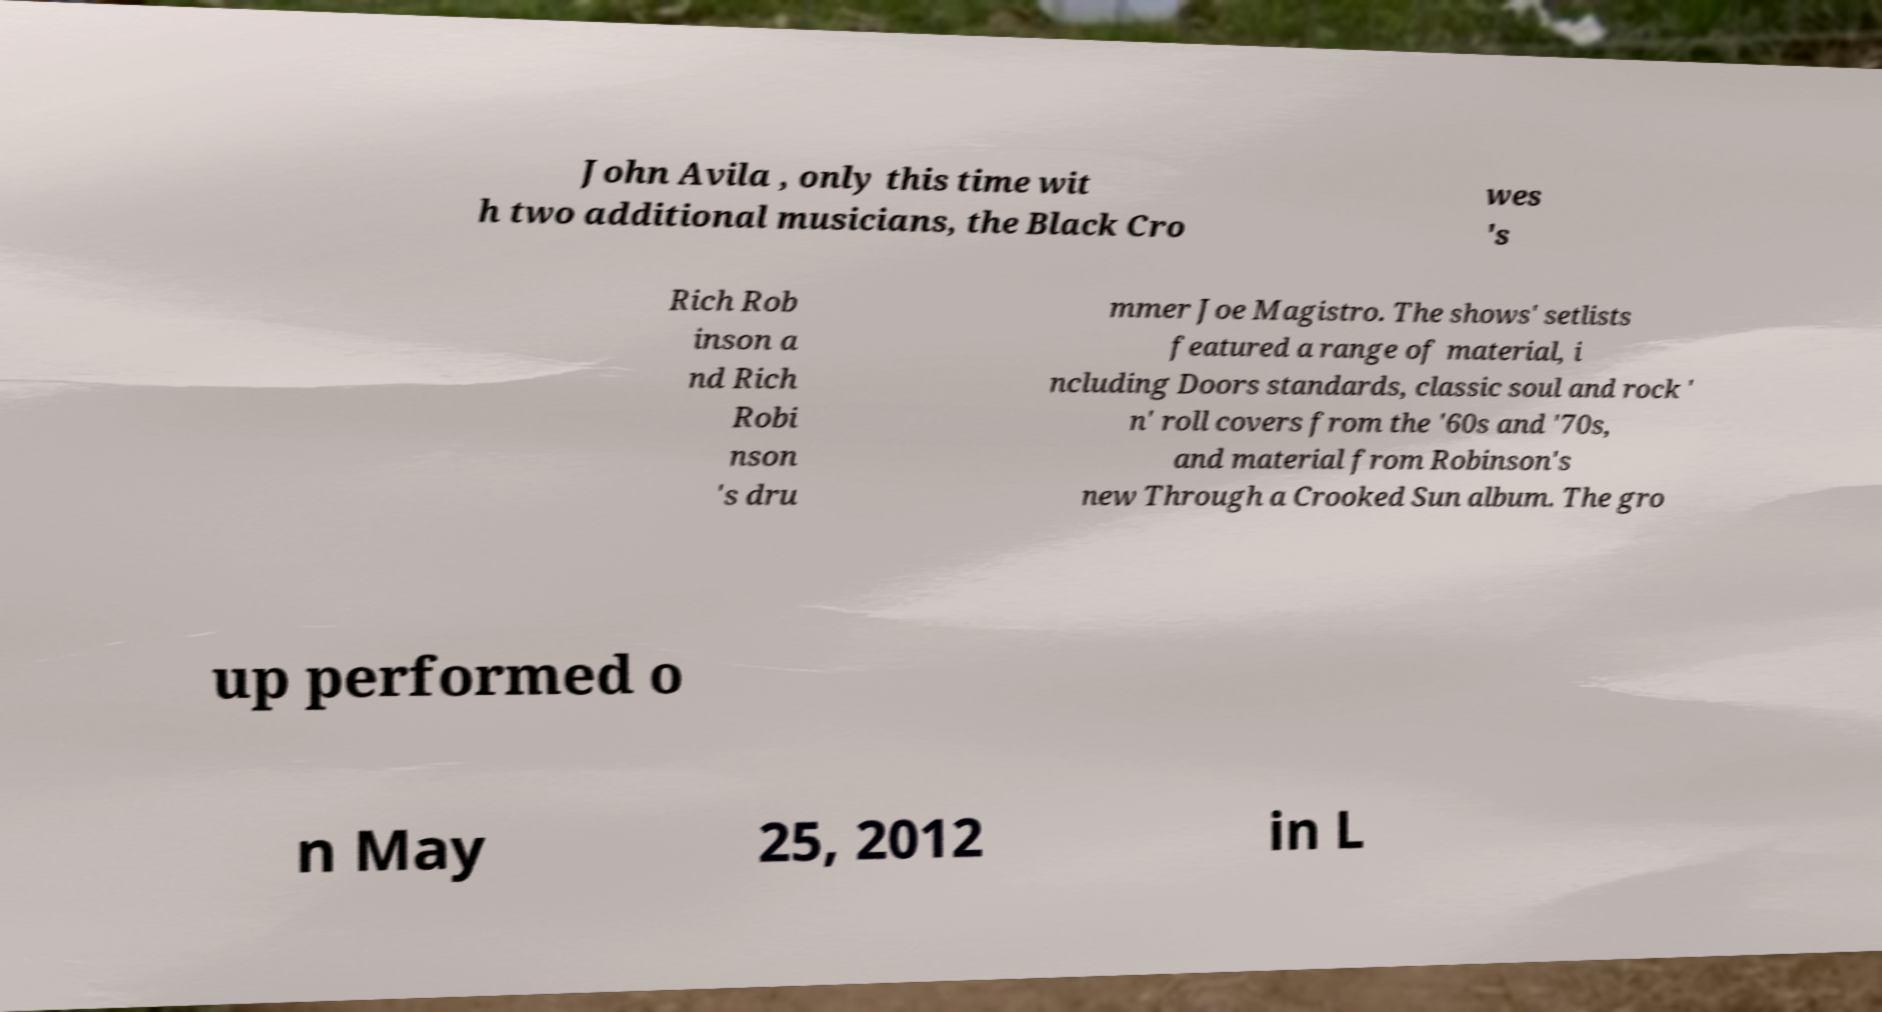Please read and relay the text visible in this image. What does it say? John Avila , only this time wit h two additional musicians, the Black Cro wes 's Rich Rob inson a nd Rich Robi nson 's dru mmer Joe Magistro. The shows' setlists featured a range of material, i ncluding Doors standards, classic soul and rock ' n' roll covers from the '60s and '70s, and material from Robinson's new Through a Crooked Sun album. The gro up performed o n May 25, 2012 in L 